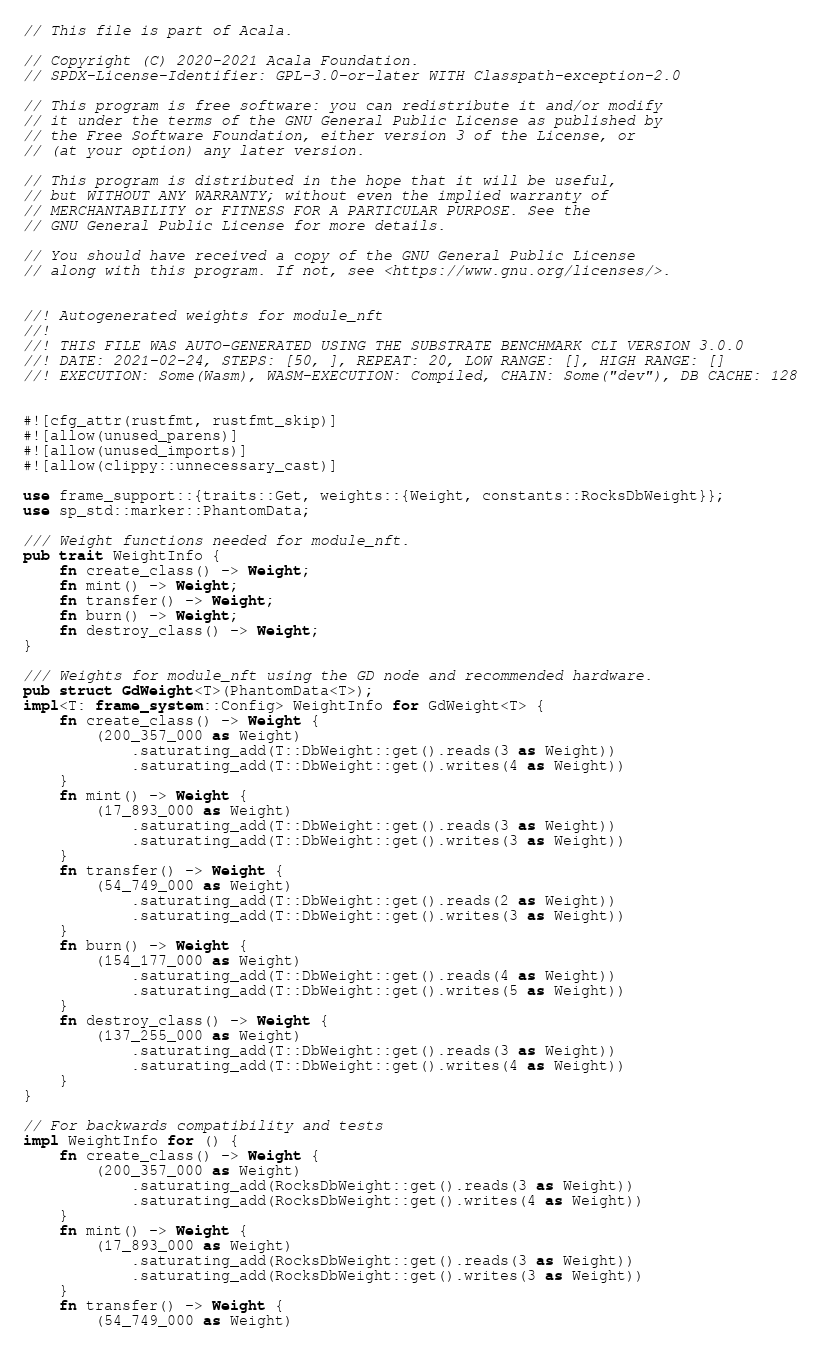<code> <loc_0><loc_0><loc_500><loc_500><_Rust_>// This file is part of Acala.

// Copyright (C) 2020-2021 Acala Foundation.
// SPDX-License-Identifier: GPL-3.0-or-later WITH Classpath-exception-2.0

// This program is free software: you can redistribute it and/or modify
// it under the terms of the GNU General Public License as published by
// the Free Software Foundation, either version 3 of the License, or
// (at your option) any later version.

// This program is distributed in the hope that it will be useful,
// but WITHOUT ANY WARRANTY; without even the implied warranty of
// MERCHANTABILITY or FITNESS FOR A PARTICULAR PURPOSE. See the
// GNU General Public License for more details.

// You should have received a copy of the GNU General Public License
// along with this program. If not, see <https://www.gnu.org/licenses/>.


//! Autogenerated weights for module_nft
//!
//! THIS FILE WAS AUTO-GENERATED USING THE SUBSTRATE BENCHMARK CLI VERSION 3.0.0
//! DATE: 2021-02-24, STEPS: [50, ], REPEAT: 20, LOW RANGE: [], HIGH RANGE: []
//! EXECUTION: Some(Wasm), WASM-EXECUTION: Compiled, CHAIN: Some("dev"), DB CACHE: 128


#![cfg_attr(rustfmt, rustfmt_skip)]
#![allow(unused_parens)]
#![allow(unused_imports)]
#![allow(clippy::unnecessary_cast)]

use frame_support::{traits::Get, weights::{Weight, constants::RocksDbWeight}};
use sp_std::marker::PhantomData;

/// Weight functions needed for module_nft.
pub trait WeightInfo {
	fn create_class() -> Weight;
	fn mint() -> Weight;
	fn transfer() -> Weight;
	fn burn() -> Weight;
	fn destroy_class() -> Weight;
}

/// Weights for module_nft using the GD node and recommended hardware.
pub struct GdWeight<T>(PhantomData<T>);
impl<T: frame_system::Config> WeightInfo for GdWeight<T> {
	fn create_class() -> Weight {
		(200_357_000 as Weight)
			.saturating_add(T::DbWeight::get().reads(3 as Weight))
			.saturating_add(T::DbWeight::get().writes(4 as Weight))
	}
	fn mint() -> Weight {
		(17_893_000 as Weight)
			.saturating_add(T::DbWeight::get().reads(3 as Weight))
			.saturating_add(T::DbWeight::get().writes(3 as Weight))
	}
	fn transfer() -> Weight {
		(54_749_000 as Weight)
			.saturating_add(T::DbWeight::get().reads(2 as Weight))
			.saturating_add(T::DbWeight::get().writes(3 as Weight))
	}
	fn burn() -> Weight {
		(154_177_000 as Weight)
			.saturating_add(T::DbWeight::get().reads(4 as Weight))
			.saturating_add(T::DbWeight::get().writes(5 as Weight))
	}
	fn destroy_class() -> Weight {
		(137_255_000 as Weight)
			.saturating_add(T::DbWeight::get().reads(3 as Weight))
			.saturating_add(T::DbWeight::get().writes(4 as Weight))
	}
}

// For backwards compatibility and tests
impl WeightInfo for () {
	fn create_class() -> Weight {
		(200_357_000 as Weight)
			.saturating_add(RocksDbWeight::get().reads(3 as Weight))
			.saturating_add(RocksDbWeight::get().writes(4 as Weight))
	}
	fn mint() -> Weight {
		(17_893_000 as Weight)
			.saturating_add(RocksDbWeight::get().reads(3 as Weight))
			.saturating_add(RocksDbWeight::get().writes(3 as Weight))
	}
	fn transfer() -> Weight {
		(54_749_000 as Weight)</code> 